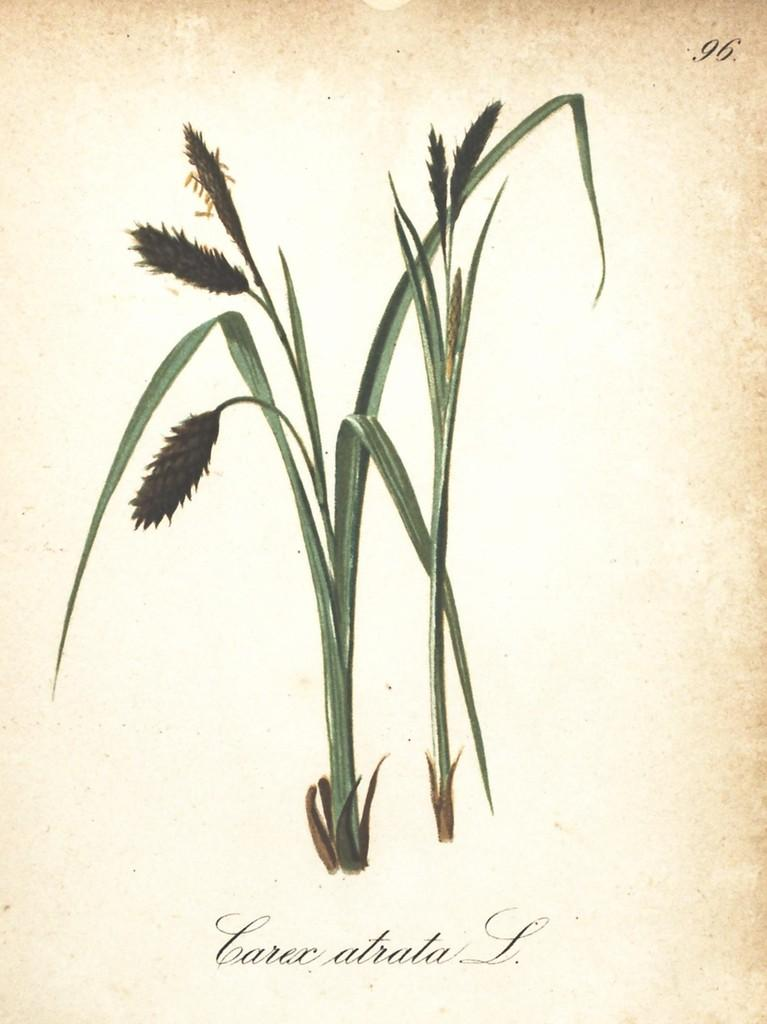What is depicted in the picture on the page? There is a picture of a plant on the page. What else can be found on the page besides the picture of the plant? There is something written on the page. What type of form is visible on the roof in the image? There is no form or roof present in the image; it only features a picture of a plant and something written on the page. 